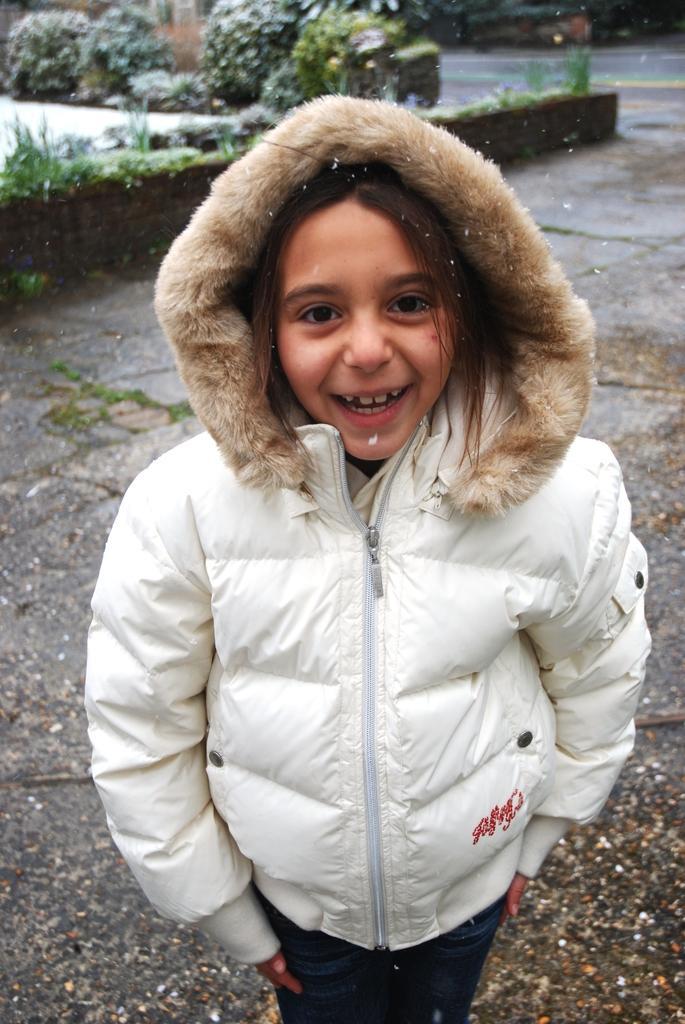Please provide a concise description of this image. Here I can see a girl wearing white color jacket, standing, smiling and giving pose for the picture. In the background, I can see some plants on the ground. 